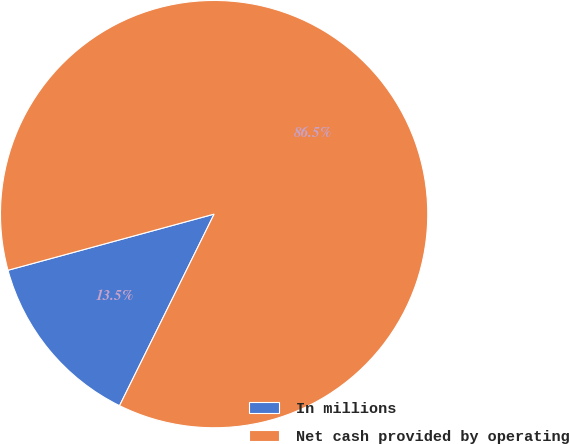Convert chart to OTSL. <chart><loc_0><loc_0><loc_500><loc_500><pie_chart><fcel>In millions<fcel>Net cash provided by operating<nl><fcel>13.47%<fcel>86.53%<nl></chart> 